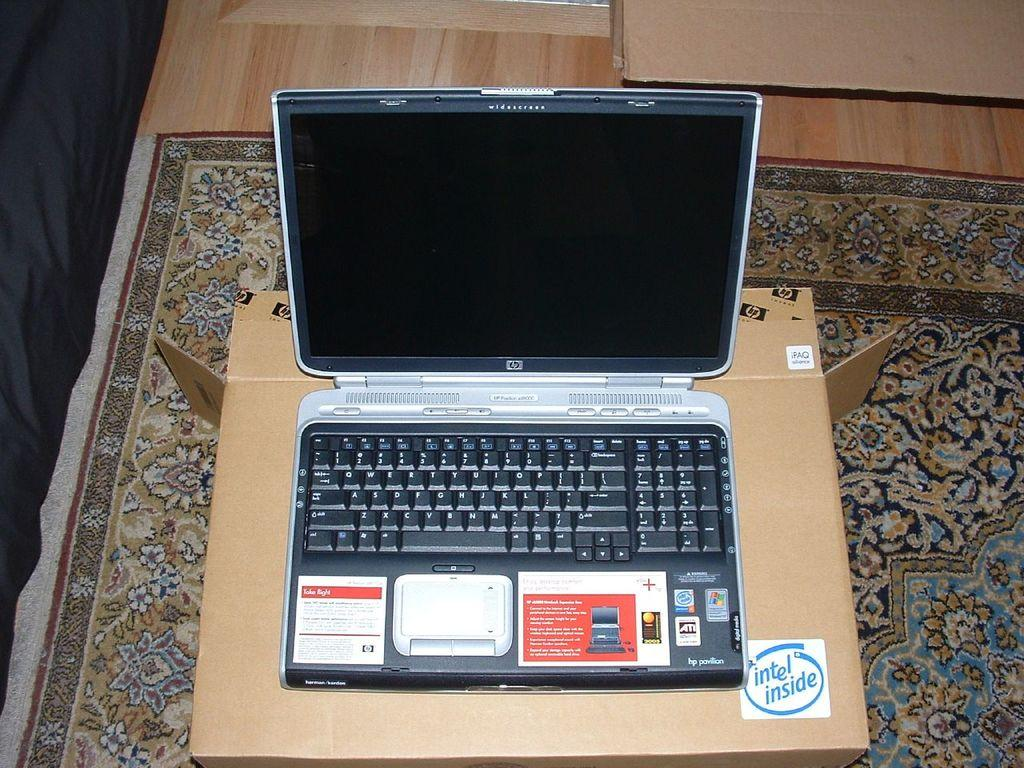<image>
Write a terse but informative summary of the picture. HP computer laptop on top of a box that says Intel Inside. 